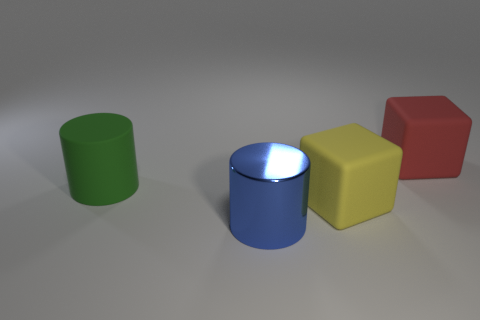Add 2 large yellow matte objects. How many objects exist? 6 Add 2 large rubber things. How many large rubber things exist? 5 Subtract 0 blue balls. How many objects are left? 4 Subtract all green rubber cylinders. Subtract all big blue cylinders. How many objects are left? 2 Add 1 large red cubes. How many large red cubes are left? 2 